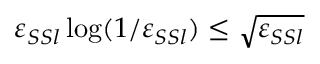Convert formula to latex. <formula><loc_0><loc_0><loc_500><loc_500>\varepsilon _ { S S l } \log ( 1 / \varepsilon _ { S S l } ) \leq \sqrt { \varepsilon _ { S S l } }</formula> 